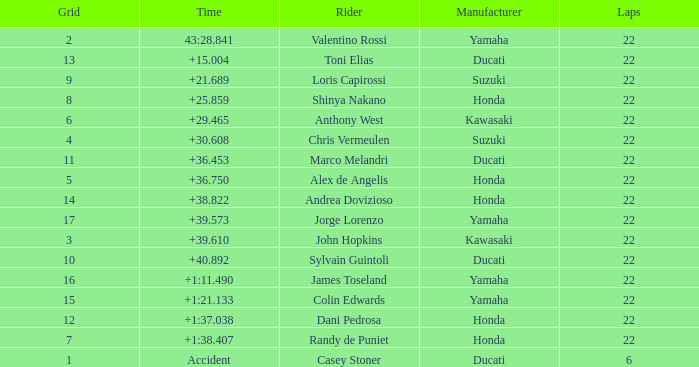Could you parse the entire table? {'header': ['Grid', 'Time', 'Rider', 'Manufacturer', 'Laps'], 'rows': [['2', '43:28.841', 'Valentino Rossi', 'Yamaha', '22'], ['13', '+15.004', 'Toni Elias', 'Ducati', '22'], ['9', '+21.689', 'Loris Capirossi', 'Suzuki', '22'], ['8', '+25.859', 'Shinya Nakano', 'Honda', '22'], ['6', '+29.465', 'Anthony West', 'Kawasaki', '22'], ['4', '+30.608', 'Chris Vermeulen', 'Suzuki', '22'], ['11', '+36.453', 'Marco Melandri', 'Ducati', '22'], ['5', '+36.750', 'Alex de Angelis', 'Honda', '22'], ['14', '+38.822', 'Andrea Dovizioso', 'Honda', '22'], ['17', '+39.573', 'Jorge Lorenzo', 'Yamaha', '22'], ['3', '+39.610', 'John Hopkins', 'Kawasaki', '22'], ['10', '+40.892', 'Sylvain Guintoli', 'Ducati', '22'], ['16', '+1:11.490', 'James Toseland', 'Yamaha', '22'], ['15', '+1:21.133', 'Colin Edwards', 'Yamaha', '22'], ['12', '+1:37.038', 'Dani Pedrosa', 'Honda', '22'], ['7', '+1:38.407', 'Randy de Puniet', 'Honda', '22'], ['1', 'Accident', 'Casey Stoner', 'Ducati', '6']]} Which grid features a ducati with less than 22 laps completed? 1.0. 